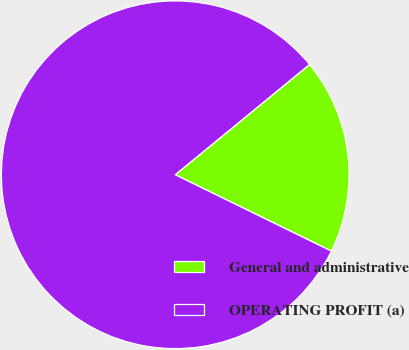Convert chart. <chart><loc_0><loc_0><loc_500><loc_500><pie_chart><fcel>General and administrative<fcel>OPERATING PROFIT (a)<nl><fcel>18.18%<fcel>81.82%<nl></chart> 